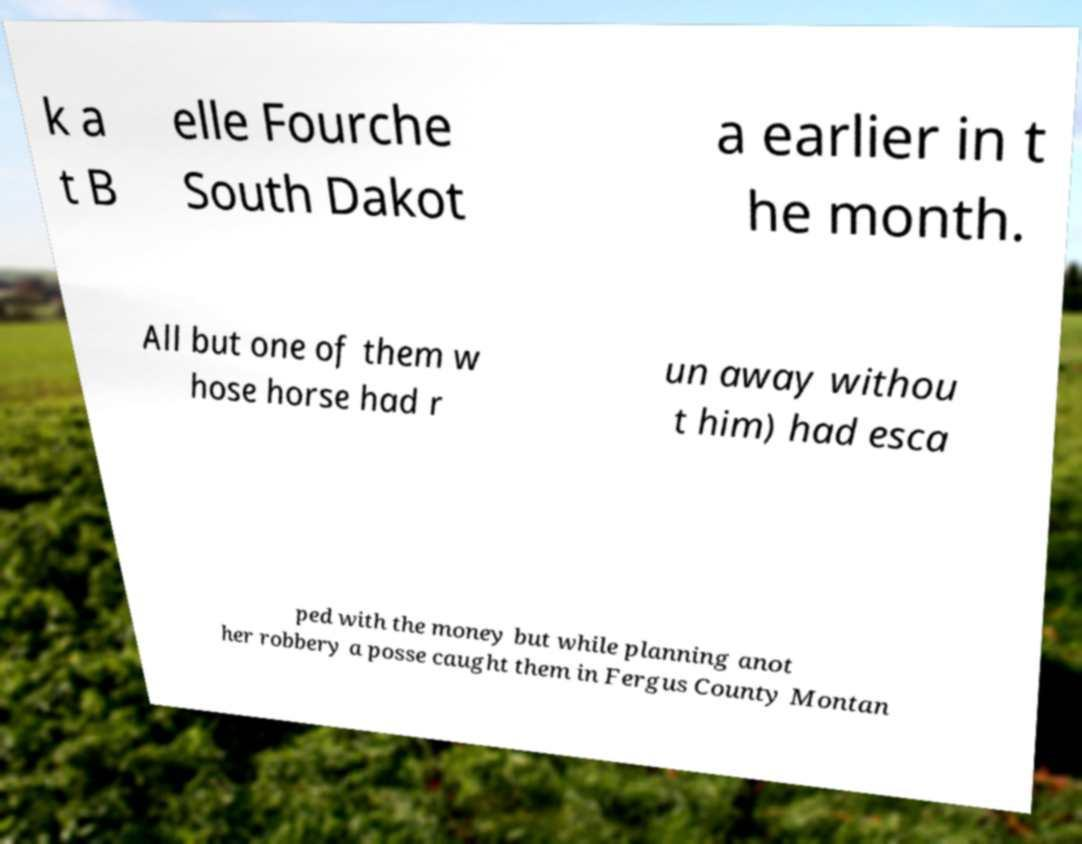There's text embedded in this image that I need extracted. Can you transcribe it verbatim? k a t B elle Fourche South Dakot a earlier in t he month. All but one of them w hose horse had r un away withou t him) had esca ped with the money but while planning anot her robbery a posse caught them in Fergus County Montan 